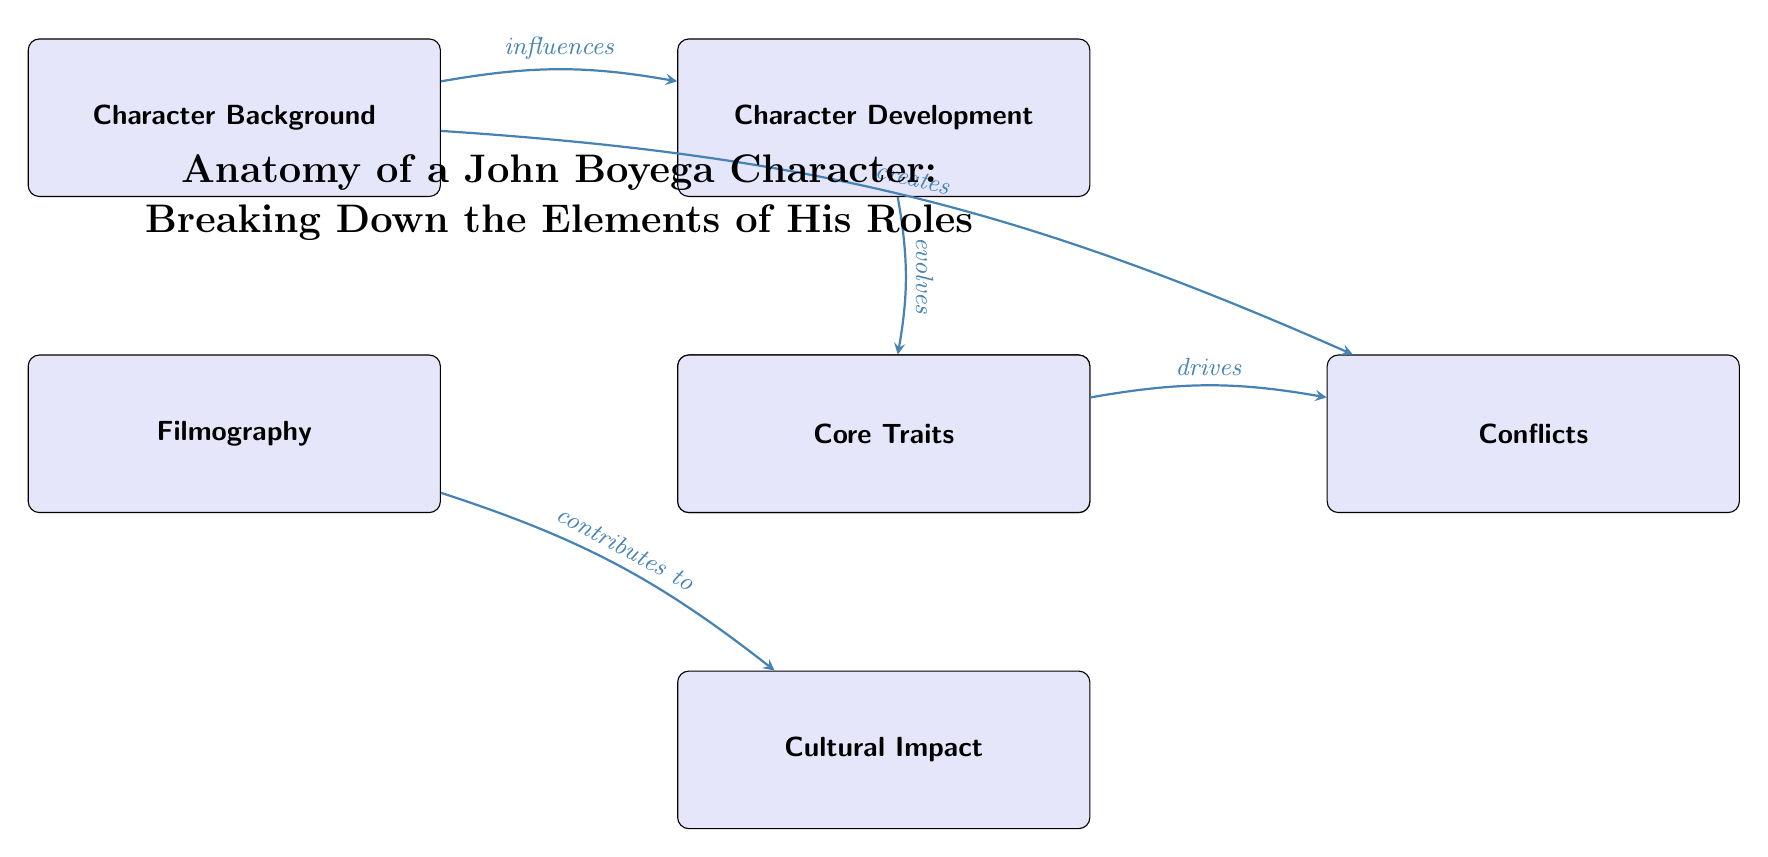What is the top node in the diagram? The top node in the diagram represents the overarching theme or concept, which is "Anatomy of a John Boyega Character: Breaking Down the Elements of His Roles." This is indicated by the larger font and central position above the other nodes.
Answer: Anatomy of a John Boyega Character: Breaking Down the Elements of His Roles How many nodes are in the diagram? By counting the boxes in the diagram, there are a total of 6 nodes including the title node. The nodes are: Character Background, Filmography, Character Development, Interactions, Core Traits, Conflicts, and Cultural Impact.
Answer: 6 What does 'Character Background' influence? The diagram indicates that 'Character Background' influences 'Character Development', as shown by the arrow pointing from the background node to the development node.
Answer: Character Development Which node does 'Core Traits' drive? According to the diagram, 'Core Traits' drives 'Conflicts', which is represented by the arrow connecting the two nodes.
Answer: Conflicts What connects 'Filmography' to 'Cultural Impact'? The arrow shows that 'Filmography' contributes to 'Cultural Impact'. Thus, the relationship is that the film roles that John Boyega has played have an impact on culture.
Answer: contributes to Which two nodes are connected by an arrow that implies a cause-effect relationship? The arrow from 'Character Background' to 'Conflicts' indicates a cause-effect relationship: the background of a character can create conflicts they face.
Answer: Character Background and Conflicts What role does 'Character Development' play in 'Interactions'? The diagram shows that 'Character Development' evolves into 'Interactions', suggesting that as a character develops, their interactions with others change as well.
Answer: evolves What does 'Interactions' impact? The diagram illustrates that 'Interactions' has an impact on 'Cultural Impact'. This suggests that the way John Boyega's characters interact influences their significance in culture.
Answer: Cultural Impact 